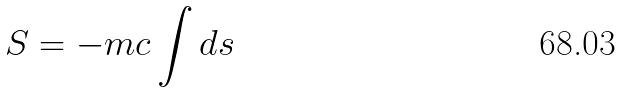<formula> <loc_0><loc_0><loc_500><loc_500>S = - m c \int d s</formula> 